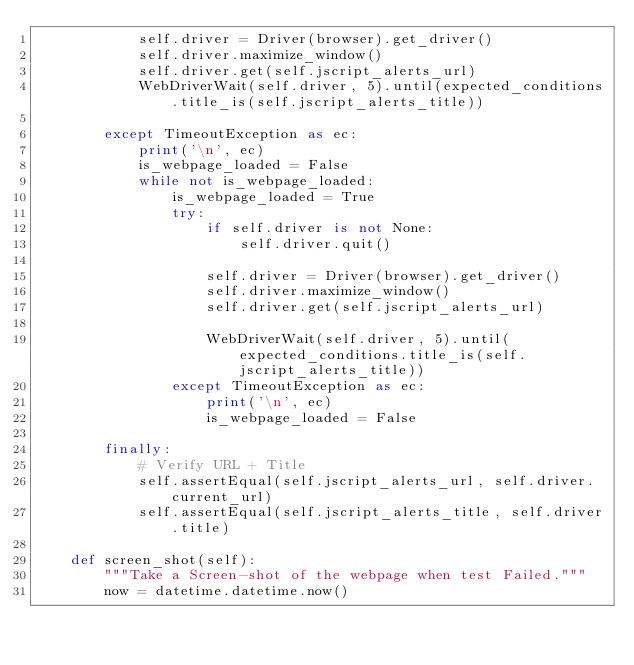Convert code to text. <code><loc_0><loc_0><loc_500><loc_500><_Python_>            self.driver = Driver(browser).get_driver()
            self.driver.maximize_window()
            self.driver.get(self.jscript_alerts_url)
            WebDriverWait(self.driver, 5).until(expected_conditions.title_is(self.jscript_alerts_title))

        except TimeoutException as ec:
            print('\n', ec)
            is_webpage_loaded = False
            while not is_webpage_loaded:
                is_webpage_loaded = True
                try:
                    if self.driver is not None:
                        self.driver.quit()

                    self.driver = Driver(browser).get_driver()
                    self.driver.maximize_window()
                    self.driver.get(self.jscript_alerts_url)

                    WebDriverWait(self.driver, 5).until(expected_conditions.title_is(self.jscript_alerts_title))
                except TimeoutException as ec:
                    print('\n', ec)
                    is_webpage_loaded = False

        finally:
            # Verify URL + Title
            self.assertEqual(self.jscript_alerts_url, self.driver.current_url)
            self.assertEqual(self.jscript_alerts_title, self.driver.title)

    def screen_shot(self):
        """Take a Screen-shot of the webpage when test Failed."""
        now = datetime.datetime.now()</code> 